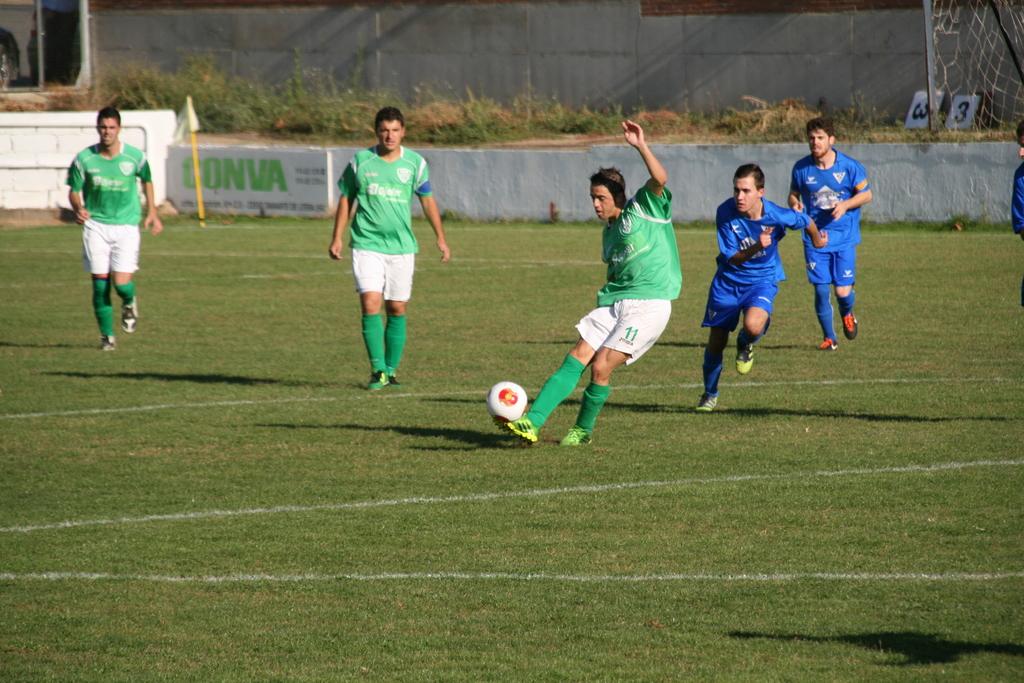What is the number of the player kicking the ball?
Give a very brief answer. 11. 